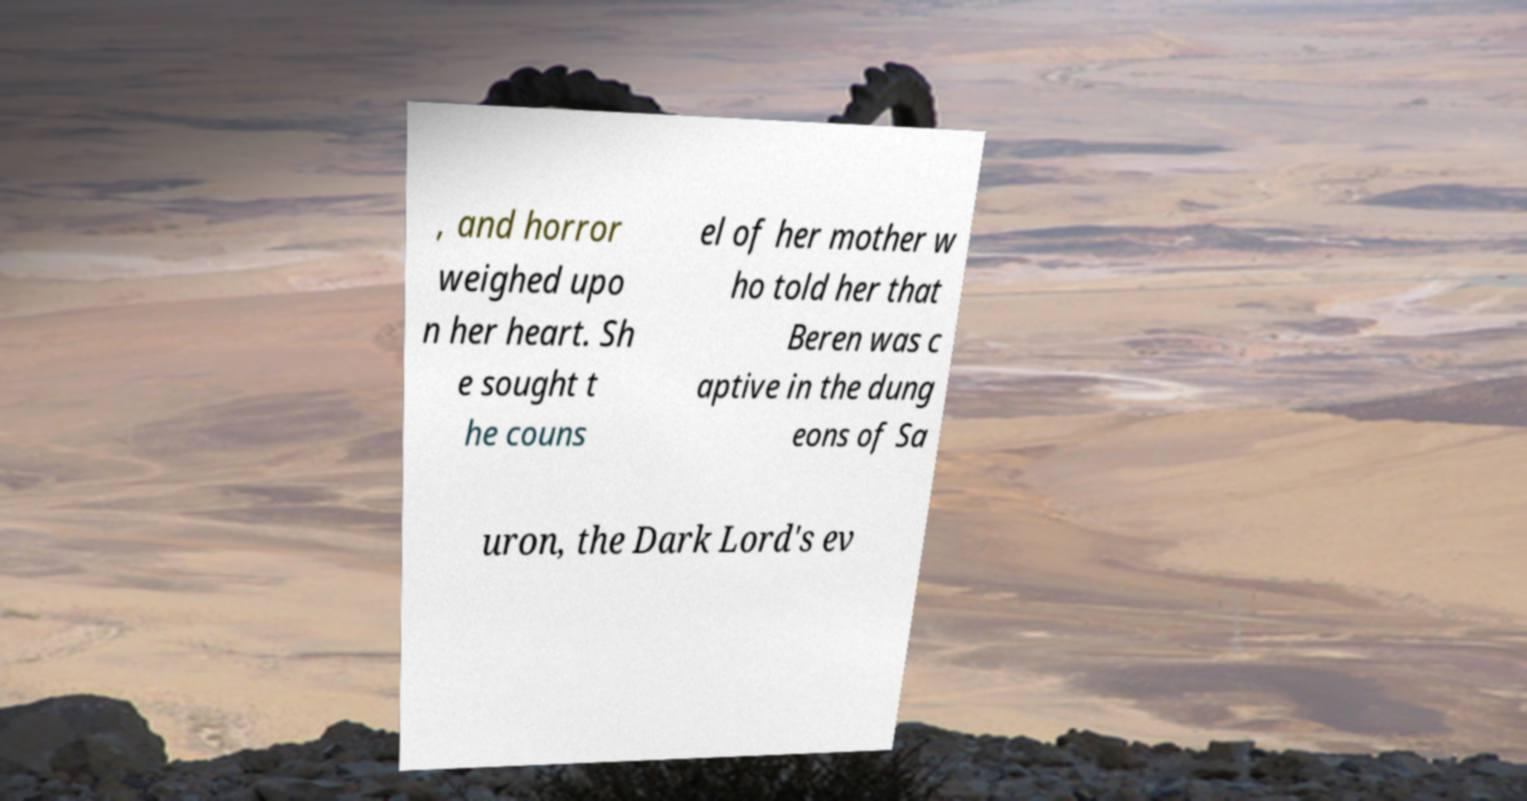I need the written content from this picture converted into text. Can you do that? , and horror weighed upo n her heart. Sh e sought t he couns el of her mother w ho told her that Beren was c aptive in the dung eons of Sa uron, the Dark Lord's ev 